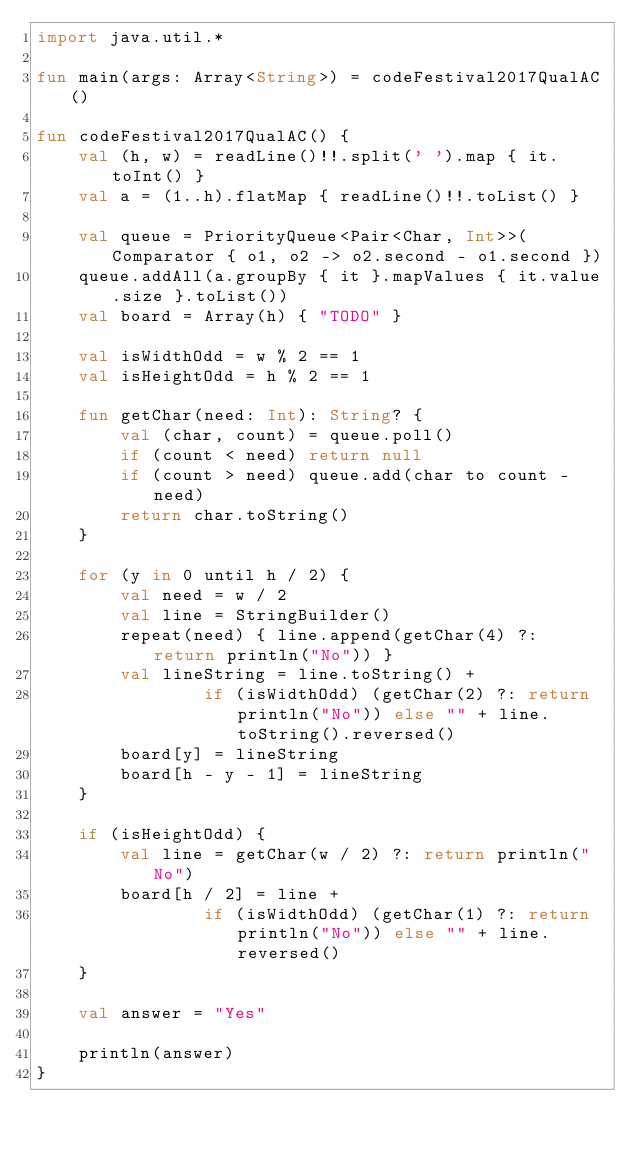Convert code to text. <code><loc_0><loc_0><loc_500><loc_500><_Kotlin_>import java.util.*

fun main(args: Array<String>) = codeFestival2017QualAC()

fun codeFestival2017QualAC() {
    val (h, w) = readLine()!!.split(' ').map { it.toInt() }
    val a = (1..h).flatMap { readLine()!!.toList() }

    val queue = PriorityQueue<Pair<Char, Int>>(Comparator { o1, o2 -> o2.second - o1.second })
    queue.addAll(a.groupBy { it }.mapValues { it.value.size }.toList())
    val board = Array(h) { "TODO" }

    val isWidthOdd = w % 2 == 1
    val isHeightOdd = h % 2 == 1

    fun getChar(need: Int): String? {
        val (char, count) = queue.poll()
        if (count < need) return null
        if (count > need) queue.add(char to count - need)
        return char.toString()
    }

    for (y in 0 until h / 2) {
        val need = w / 2
        val line = StringBuilder()
        repeat(need) { line.append(getChar(4) ?: return println("No")) }
        val lineString = line.toString() +
                if (isWidthOdd) (getChar(2) ?: return println("No")) else "" + line.toString().reversed()
        board[y] = lineString
        board[h - y - 1] = lineString
    }

    if (isHeightOdd) {
        val line = getChar(w / 2) ?: return println("No")
        board[h / 2] = line +
                if (isWidthOdd) (getChar(1) ?: return println("No")) else "" + line.reversed()
    }

    val answer = "Yes"

    println(answer)
}
</code> 